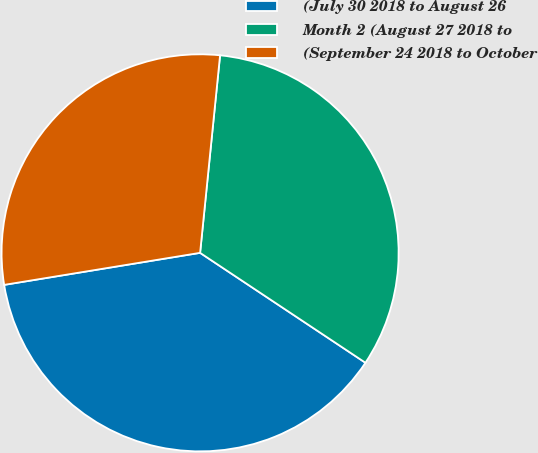Convert chart to OTSL. <chart><loc_0><loc_0><loc_500><loc_500><pie_chart><fcel>(July 30 2018 to August 26<fcel>Month 2 (August 27 2018 to<fcel>(September 24 2018 to October<nl><fcel>38.08%<fcel>32.73%<fcel>29.18%<nl></chart> 